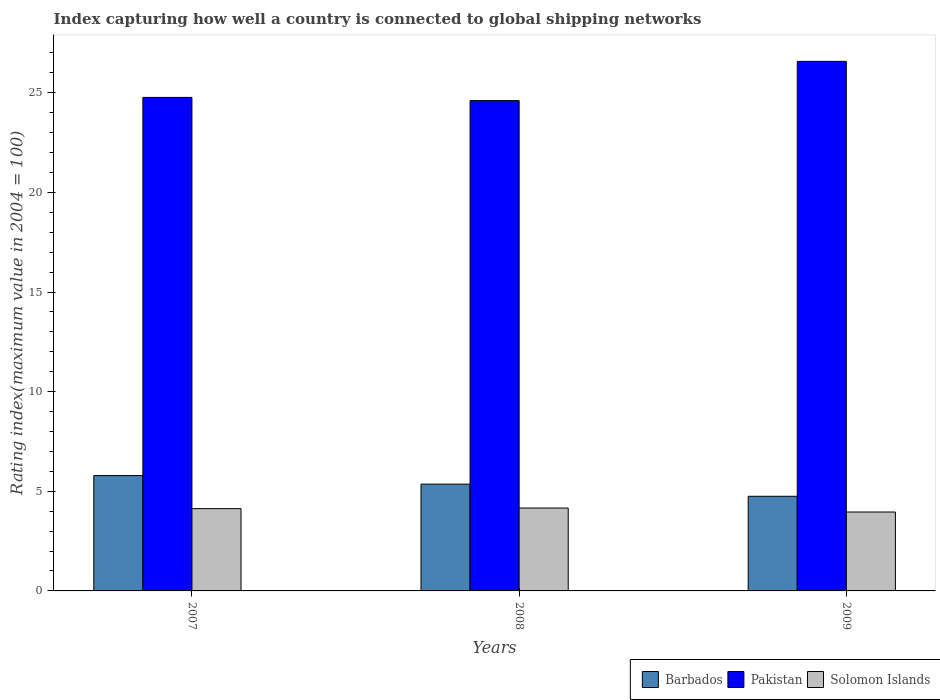How many different coloured bars are there?
Provide a short and direct response. 3. Are the number of bars on each tick of the X-axis equal?
Offer a very short reply. Yes. How many bars are there on the 1st tick from the right?
Make the answer very short. 3. What is the label of the 3rd group of bars from the left?
Offer a very short reply. 2009. What is the rating index in Pakistan in 2008?
Your answer should be very brief. 24.61. Across all years, what is the maximum rating index in Barbados?
Ensure brevity in your answer.  5.79. Across all years, what is the minimum rating index in Solomon Islands?
Ensure brevity in your answer.  3.96. In which year was the rating index in Pakistan maximum?
Make the answer very short. 2009. What is the total rating index in Barbados in the graph?
Provide a short and direct response. 15.9. What is the difference between the rating index in Solomon Islands in 2007 and that in 2008?
Make the answer very short. -0.03. What is the difference between the rating index in Solomon Islands in 2008 and the rating index in Pakistan in 2007?
Your answer should be very brief. -20.61. What is the average rating index in Solomon Islands per year?
Your answer should be very brief. 4.08. In the year 2008, what is the difference between the rating index in Pakistan and rating index in Barbados?
Your response must be concise. 19.25. In how many years, is the rating index in Solomon Islands greater than 1?
Your response must be concise. 3. What is the ratio of the rating index in Solomon Islands in 2007 to that in 2009?
Keep it short and to the point. 1.04. What is the difference between the highest and the second highest rating index in Barbados?
Your answer should be very brief. 0.43. What is the difference between the highest and the lowest rating index in Barbados?
Make the answer very short. 1.04. In how many years, is the rating index in Pakistan greater than the average rating index in Pakistan taken over all years?
Ensure brevity in your answer.  1. Is the sum of the rating index in Solomon Islands in 2007 and 2009 greater than the maximum rating index in Pakistan across all years?
Keep it short and to the point. No. What does the 3rd bar from the left in 2008 represents?
Keep it short and to the point. Solomon Islands. What does the 1st bar from the right in 2009 represents?
Make the answer very short. Solomon Islands. How many years are there in the graph?
Give a very brief answer. 3. What is the difference between two consecutive major ticks on the Y-axis?
Offer a terse response. 5. Are the values on the major ticks of Y-axis written in scientific E-notation?
Ensure brevity in your answer.  No. Does the graph contain any zero values?
Provide a succinct answer. No. How many legend labels are there?
Provide a succinct answer. 3. How are the legend labels stacked?
Provide a succinct answer. Horizontal. What is the title of the graph?
Offer a very short reply. Index capturing how well a country is connected to global shipping networks. Does "Armenia" appear as one of the legend labels in the graph?
Keep it short and to the point. No. What is the label or title of the Y-axis?
Provide a short and direct response. Rating index(maximum value in 2004 = 100). What is the Rating index(maximum value in 2004 = 100) of Barbados in 2007?
Your answer should be very brief. 5.79. What is the Rating index(maximum value in 2004 = 100) in Pakistan in 2007?
Your answer should be compact. 24.77. What is the Rating index(maximum value in 2004 = 100) in Solomon Islands in 2007?
Make the answer very short. 4.13. What is the Rating index(maximum value in 2004 = 100) in Barbados in 2008?
Your answer should be very brief. 5.36. What is the Rating index(maximum value in 2004 = 100) in Pakistan in 2008?
Provide a short and direct response. 24.61. What is the Rating index(maximum value in 2004 = 100) of Solomon Islands in 2008?
Keep it short and to the point. 4.16. What is the Rating index(maximum value in 2004 = 100) of Barbados in 2009?
Provide a short and direct response. 4.75. What is the Rating index(maximum value in 2004 = 100) of Pakistan in 2009?
Give a very brief answer. 26.58. What is the Rating index(maximum value in 2004 = 100) of Solomon Islands in 2009?
Ensure brevity in your answer.  3.96. Across all years, what is the maximum Rating index(maximum value in 2004 = 100) in Barbados?
Offer a terse response. 5.79. Across all years, what is the maximum Rating index(maximum value in 2004 = 100) in Pakistan?
Make the answer very short. 26.58. Across all years, what is the maximum Rating index(maximum value in 2004 = 100) in Solomon Islands?
Provide a short and direct response. 4.16. Across all years, what is the minimum Rating index(maximum value in 2004 = 100) in Barbados?
Your answer should be compact. 4.75. Across all years, what is the minimum Rating index(maximum value in 2004 = 100) in Pakistan?
Your answer should be very brief. 24.61. Across all years, what is the minimum Rating index(maximum value in 2004 = 100) of Solomon Islands?
Give a very brief answer. 3.96. What is the total Rating index(maximum value in 2004 = 100) in Barbados in the graph?
Offer a very short reply. 15.9. What is the total Rating index(maximum value in 2004 = 100) in Pakistan in the graph?
Provide a short and direct response. 75.96. What is the total Rating index(maximum value in 2004 = 100) in Solomon Islands in the graph?
Offer a very short reply. 12.25. What is the difference between the Rating index(maximum value in 2004 = 100) of Barbados in 2007 and that in 2008?
Give a very brief answer. 0.43. What is the difference between the Rating index(maximum value in 2004 = 100) of Pakistan in 2007 and that in 2008?
Offer a terse response. 0.16. What is the difference between the Rating index(maximum value in 2004 = 100) in Solomon Islands in 2007 and that in 2008?
Provide a succinct answer. -0.03. What is the difference between the Rating index(maximum value in 2004 = 100) in Barbados in 2007 and that in 2009?
Make the answer very short. 1.04. What is the difference between the Rating index(maximum value in 2004 = 100) in Pakistan in 2007 and that in 2009?
Ensure brevity in your answer.  -1.81. What is the difference between the Rating index(maximum value in 2004 = 100) of Solomon Islands in 2007 and that in 2009?
Your answer should be very brief. 0.17. What is the difference between the Rating index(maximum value in 2004 = 100) in Barbados in 2008 and that in 2009?
Provide a succinct answer. 0.61. What is the difference between the Rating index(maximum value in 2004 = 100) in Pakistan in 2008 and that in 2009?
Keep it short and to the point. -1.97. What is the difference between the Rating index(maximum value in 2004 = 100) in Barbados in 2007 and the Rating index(maximum value in 2004 = 100) in Pakistan in 2008?
Ensure brevity in your answer.  -18.82. What is the difference between the Rating index(maximum value in 2004 = 100) in Barbados in 2007 and the Rating index(maximum value in 2004 = 100) in Solomon Islands in 2008?
Your answer should be compact. 1.63. What is the difference between the Rating index(maximum value in 2004 = 100) of Pakistan in 2007 and the Rating index(maximum value in 2004 = 100) of Solomon Islands in 2008?
Your response must be concise. 20.61. What is the difference between the Rating index(maximum value in 2004 = 100) of Barbados in 2007 and the Rating index(maximum value in 2004 = 100) of Pakistan in 2009?
Keep it short and to the point. -20.79. What is the difference between the Rating index(maximum value in 2004 = 100) of Barbados in 2007 and the Rating index(maximum value in 2004 = 100) of Solomon Islands in 2009?
Your response must be concise. 1.83. What is the difference between the Rating index(maximum value in 2004 = 100) of Pakistan in 2007 and the Rating index(maximum value in 2004 = 100) of Solomon Islands in 2009?
Provide a short and direct response. 20.81. What is the difference between the Rating index(maximum value in 2004 = 100) of Barbados in 2008 and the Rating index(maximum value in 2004 = 100) of Pakistan in 2009?
Make the answer very short. -21.22. What is the difference between the Rating index(maximum value in 2004 = 100) in Pakistan in 2008 and the Rating index(maximum value in 2004 = 100) in Solomon Islands in 2009?
Your response must be concise. 20.65. What is the average Rating index(maximum value in 2004 = 100) of Pakistan per year?
Make the answer very short. 25.32. What is the average Rating index(maximum value in 2004 = 100) in Solomon Islands per year?
Offer a very short reply. 4.08. In the year 2007, what is the difference between the Rating index(maximum value in 2004 = 100) of Barbados and Rating index(maximum value in 2004 = 100) of Pakistan?
Offer a very short reply. -18.98. In the year 2007, what is the difference between the Rating index(maximum value in 2004 = 100) of Barbados and Rating index(maximum value in 2004 = 100) of Solomon Islands?
Your answer should be very brief. 1.66. In the year 2007, what is the difference between the Rating index(maximum value in 2004 = 100) in Pakistan and Rating index(maximum value in 2004 = 100) in Solomon Islands?
Provide a succinct answer. 20.64. In the year 2008, what is the difference between the Rating index(maximum value in 2004 = 100) in Barbados and Rating index(maximum value in 2004 = 100) in Pakistan?
Give a very brief answer. -19.25. In the year 2008, what is the difference between the Rating index(maximum value in 2004 = 100) in Barbados and Rating index(maximum value in 2004 = 100) in Solomon Islands?
Make the answer very short. 1.2. In the year 2008, what is the difference between the Rating index(maximum value in 2004 = 100) in Pakistan and Rating index(maximum value in 2004 = 100) in Solomon Islands?
Provide a succinct answer. 20.45. In the year 2009, what is the difference between the Rating index(maximum value in 2004 = 100) of Barbados and Rating index(maximum value in 2004 = 100) of Pakistan?
Make the answer very short. -21.83. In the year 2009, what is the difference between the Rating index(maximum value in 2004 = 100) of Barbados and Rating index(maximum value in 2004 = 100) of Solomon Islands?
Offer a terse response. 0.79. In the year 2009, what is the difference between the Rating index(maximum value in 2004 = 100) in Pakistan and Rating index(maximum value in 2004 = 100) in Solomon Islands?
Ensure brevity in your answer.  22.62. What is the ratio of the Rating index(maximum value in 2004 = 100) of Barbados in 2007 to that in 2008?
Provide a short and direct response. 1.08. What is the ratio of the Rating index(maximum value in 2004 = 100) of Solomon Islands in 2007 to that in 2008?
Your response must be concise. 0.99. What is the ratio of the Rating index(maximum value in 2004 = 100) of Barbados in 2007 to that in 2009?
Provide a succinct answer. 1.22. What is the ratio of the Rating index(maximum value in 2004 = 100) of Pakistan in 2007 to that in 2009?
Provide a succinct answer. 0.93. What is the ratio of the Rating index(maximum value in 2004 = 100) of Solomon Islands in 2007 to that in 2009?
Make the answer very short. 1.04. What is the ratio of the Rating index(maximum value in 2004 = 100) in Barbados in 2008 to that in 2009?
Your answer should be very brief. 1.13. What is the ratio of the Rating index(maximum value in 2004 = 100) of Pakistan in 2008 to that in 2009?
Provide a succinct answer. 0.93. What is the ratio of the Rating index(maximum value in 2004 = 100) of Solomon Islands in 2008 to that in 2009?
Make the answer very short. 1.05. What is the difference between the highest and the second highest Rating index(maximum value in 2004 = 100) of Barbados?
Provide a short and direct response. 0.43. What is the difference between the highest and the second highest Rating index(maximum value in 2004 = 100) in Pakistan?
Your response must be concise. 1.81. What is the difference between the highest and the second highest Rating index(maximum value in 2004 = 100) of Solomon Islands?
Your answer should be very brief. 0.03. What is the difference between the highest and the lowest Rating index(maximum value in 2004 = 100) of Barbados?
Offer a very short reply. 1.04. What is the difference between the highest and the lowest Rating index(maximum value in 2004 = 100) in Pakistan?
Offer a terse response. 1.97. What is the difference between the highest and the lowest Rating index(maximum value in 2004 = 100) in Solomon Islands?
Make the answer very short. 0.2. 